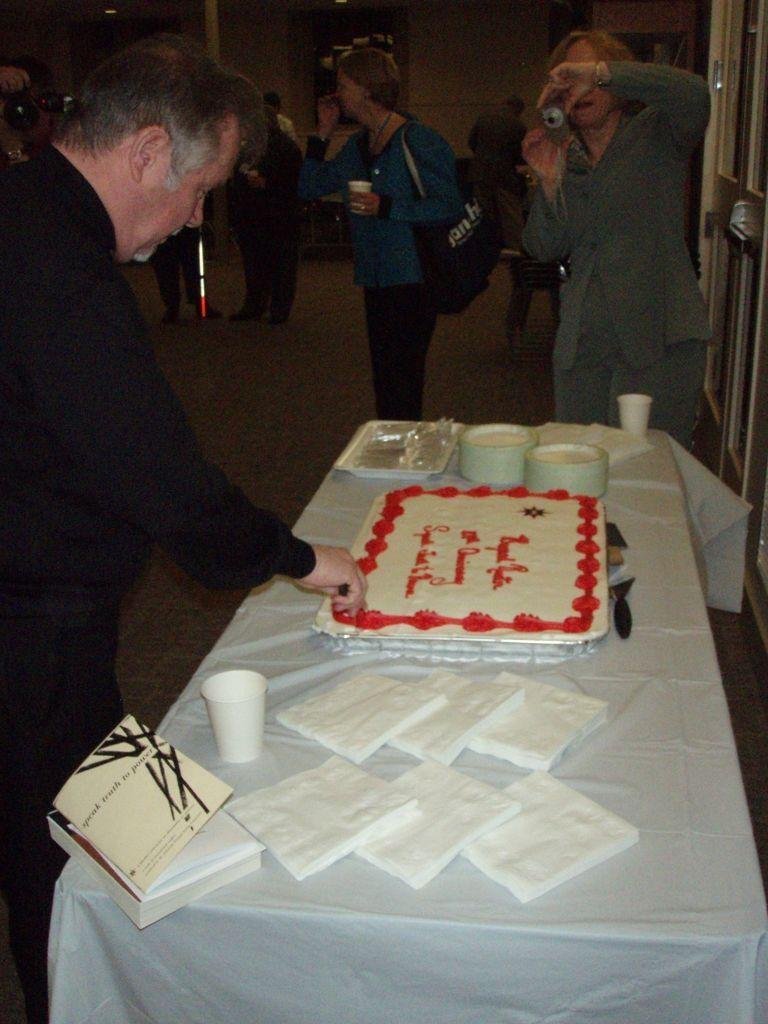Who is the main subject on the left side of the image? There is a man in the image, and he is standing on the left side. What is the man doing in the image? The man is cutting a cake in the image. Where is the cake located in the image? The cake is on a table in the image. Who is the other person in the image? There is a woman in the image, and she is on the right side. What is the woman doing in the image? The woman is clicking a picture in the image. What type of stem can be seen growing from the cake in the image? There is no stem growing from the cake in the image; it is a cake being cut by a man. Is there a harbor visible in the background of the image? There is no harbor present in the image; it features a man cutting a cake and a woman clicking a picture. 